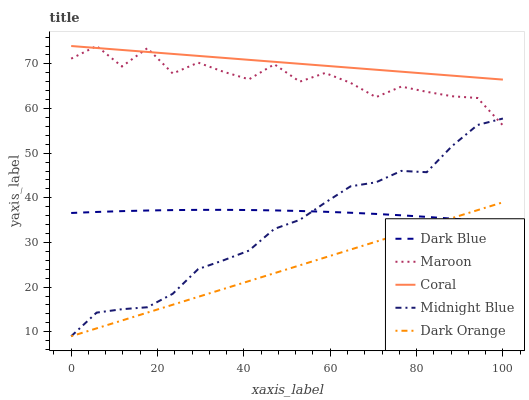Does Dark Orange have the minimum area under the curve?
Answer yes or no. Yes. Does Coral have the maximum area under the curve?
Answer yes or no. Yes. Does Midnight Blue have the minimum area under the curve?
Answer yes or no. No. Does Midnight Blue have the maximum area under the curve?
Answer yes or no. No. Is Dark Orange the smoothest?
Answer yes or no. Yes. Is Maroon the roughest?
Answer yes or no. Yes. Is Coral the smoothest?
Answer yes or no. No. Is Coral the roughest?
Answer yes or no. No. Does Coral have the lowest value?
Answer yes or no. No. Does Maroon have the highest value?
Answer yes or no. Yes. Does Midnight Blue have the highest value?
Answer yes or no. No. Is Midnight Blue less than Coral?
Answer yes or no. Yes. Is Coral greater than Dark Orange?
Answer yes or no. Yes. Does Dark Blue intersect Midnight Blue?
Answer yes or no. Yes. Is Dark Blue less than Midnight Blue?
Answer yes or no. No. Is Dark Blue greater than Midnight Blue?
Answer yes or no. No. Does Midnight Blue intersect Coral?
Answer yes or no. No. 